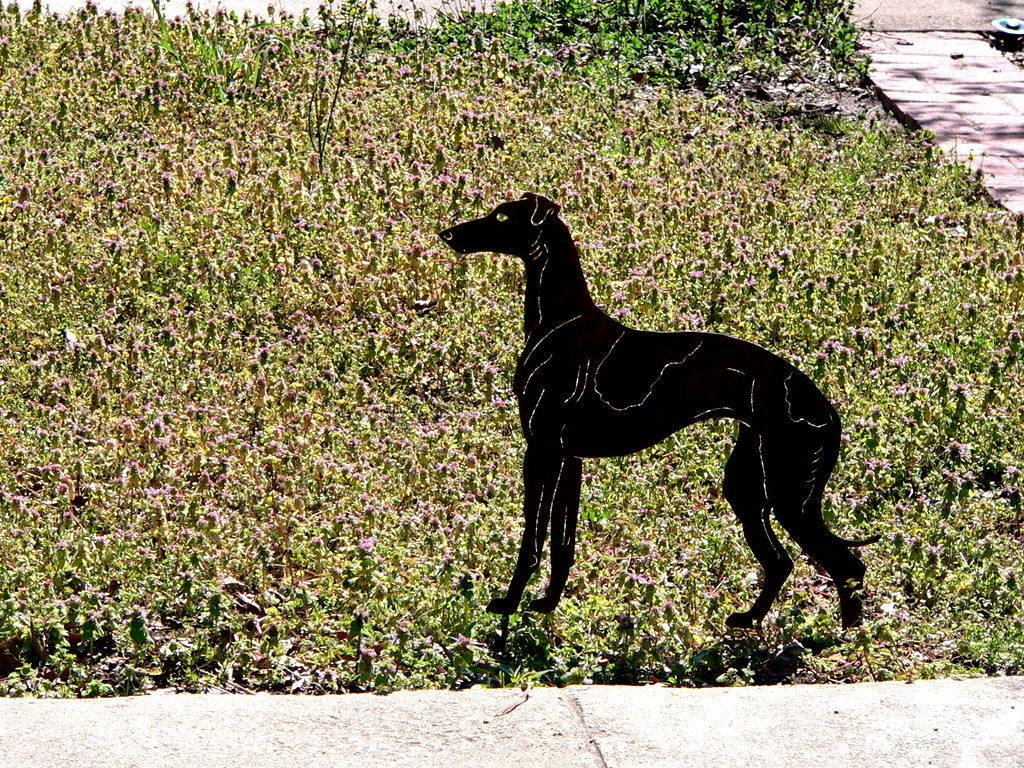What type of living organisms can be seen in the image? There are flowers and plants in the image. What is the animated character in the image? There is a black color animated dog in the image. What color is the crayon used to draw the dog in the image? There is no crayon present in the image, as the dog is an animated character. Who is the owner of the dog in the image? There is no owner present in the image, as the dog is an animated character. 